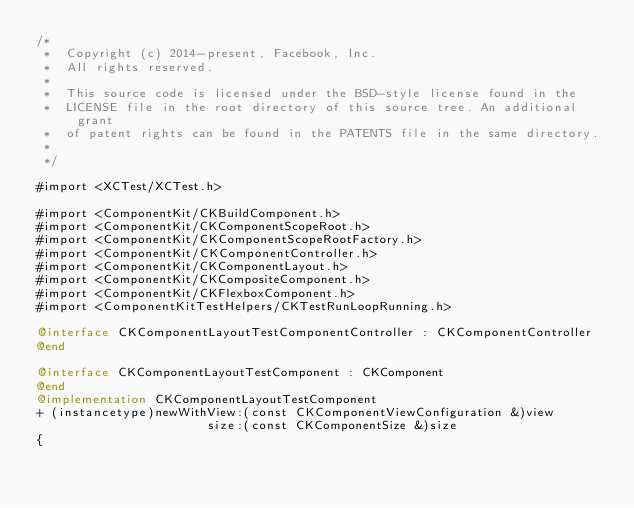Convert code to text. <code><loc_0><loc_0><loc_500><loc_500><_ObjectiveC_>/*
 *  Copyright (c) 2014-present, Facebook, Inc.
 *  All rights reserved.
 *
 *  This source code is licensed under the BSD-style license found in the
 *  LICENSE file in the root directory of this source tree. An additional grant
 *  of patent rights can be found in the PATENTS file in the same directory.
 *
 */

#import <XCTest/XCTest.h>

#import <ComponentKit/CKBuildComponent.h>
#import <ComponentKit/CKComponentScopeRoot.h>
#import <ComponentKit/CKComponentScopeRootFactory.h>
#import <ComponentKit/CKComponentController.h>
#import <ComponentKit/CKComponentLayout.h>
#import <ComponentKit/CKCompositeComponent.h>
#import <ComponentKit/CKFlexboxComponent.h>
#import <ComponentKitTestHelpers/CKTestRunLoopRunning.h>

@interface CKComponentLayoutTestComponentController : CKComponentController
@end

@interface CKComponentLayoutTestComponent : CKComponent
@end
@implementation CKComponentLayoutTestComponent
+ (instancetype)newWithView:(const CKComponentViewConfiguration &)view
                       size:(const CKComponentSize &)size
{</code> 